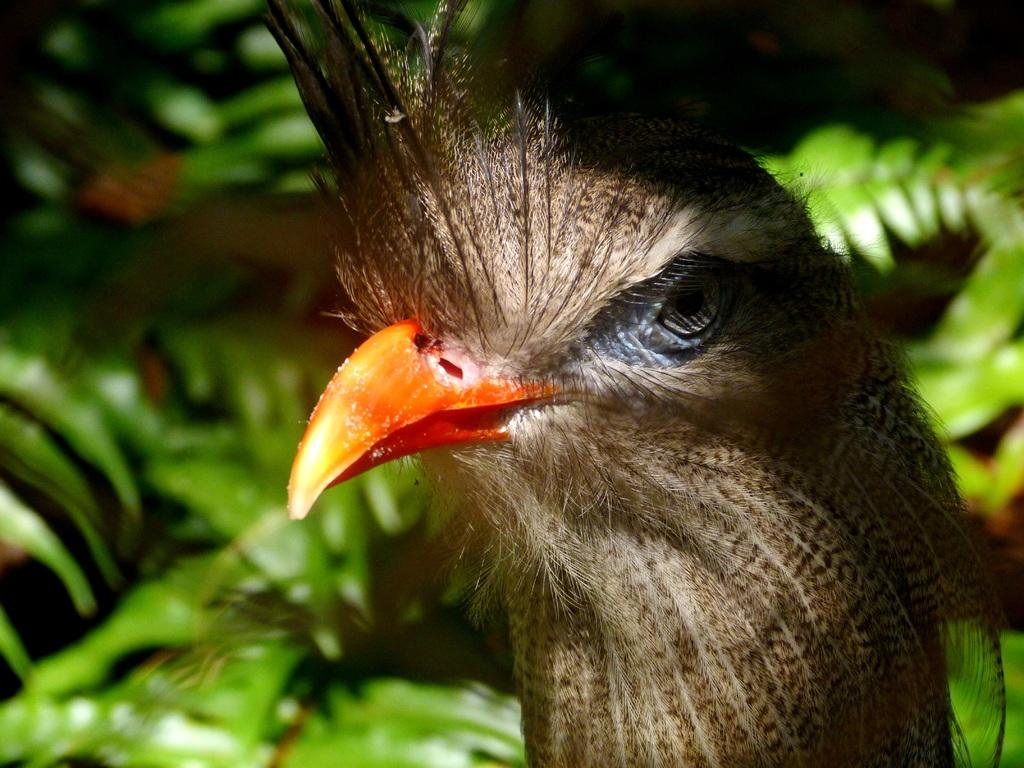What type of animal is present in the image? There is a bird in the image. What can be seen in the background of the image? There are trees in the background of the image. What type of yak can be seen grazing in the image? There is no yak present in the image; it features a bird and trees in the background. 